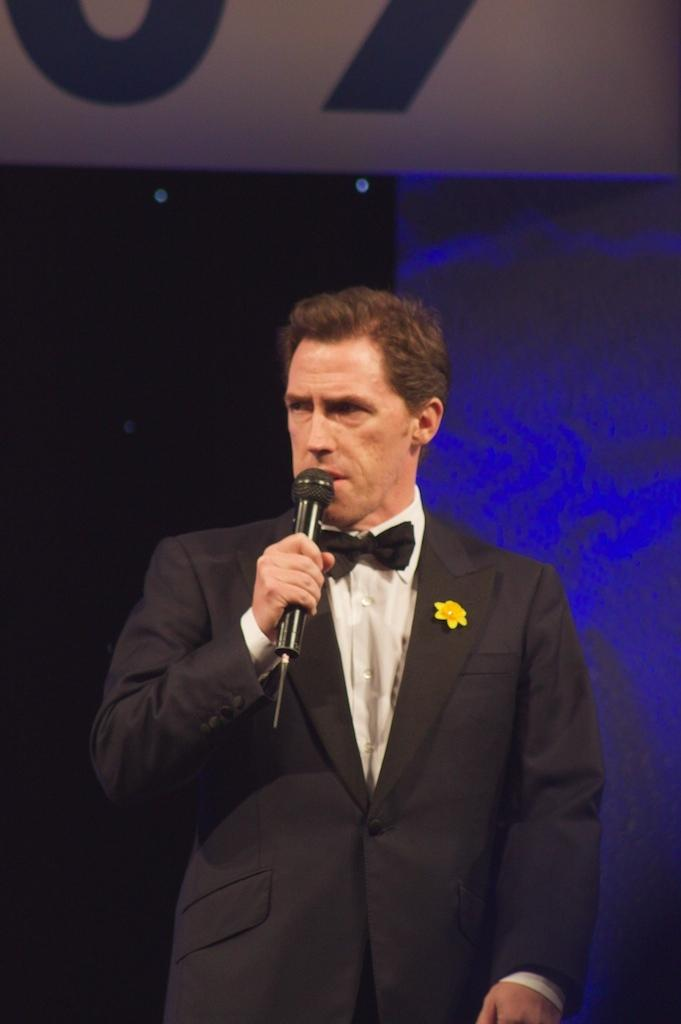Who is the main subject in the image? There is a man in the image. What is the man doing in the image? The man is standing and speaking in the image. What object is the man holding in his hand? The man is holding a microphone in his hand. What type of gun is the man holding in the image? There is no gun present in the image; the man is holding a microphone. What type of horn is the man using to make noise in the image? There is no horn present in the image; the man is speaking into a microphone. 